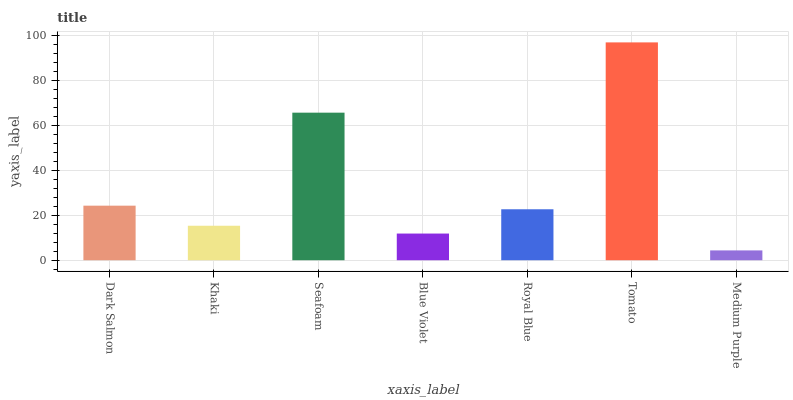Is Medium Purple the minimum?
Answer yes or no. Yes. Is Tomato the maximum?
Answer yes or no. Yes. Is Khaki the minimum?
Answer yes or no. No. Is Khaki the maximum?
Answer yes or no. No. Is Dark Salmon greater than Khaki?
Answer yes or no. Yes. Is Khaki less than Dark Salmon?
Answer yes or no. Yes. Is Khaki greater than Dark Salmon?
Answer yes or no. No. Is Dark Salmon less than Khaki?
Answer yes or no. No. Is Royal Blue the high median?
Answer yes or no. Yes. Is Royal Blue the low median?
Answer yes or no. Yes. Is Dark Salmon the high median?
Answer yes or no. No. Is Medium Purple the low median?
Answer yes or no. No. 